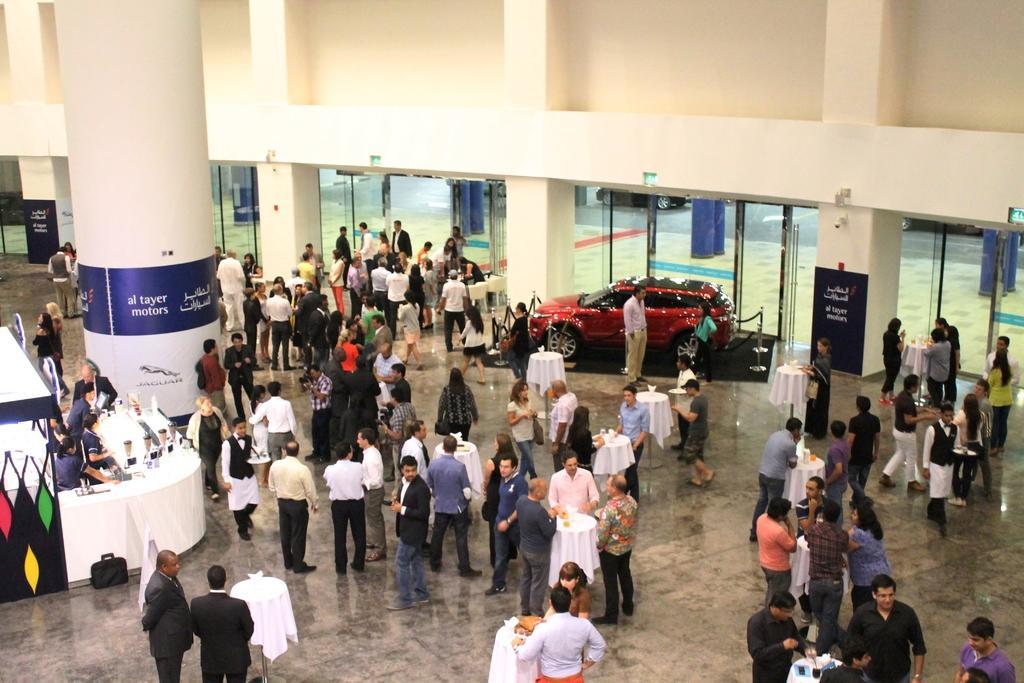How would you summarize this image in a sentence or two? On the left side, there are persons standing in front of a table on which, there are glasses and it is covered with white color cloth near a suitcase which is on the floor on which, there are persons standing, there are tables on which there are some objects, there is a pillar on which, there are posters and there is wall. In the background, there is a road on which, there are vehicles and there are violet colored pillars. 